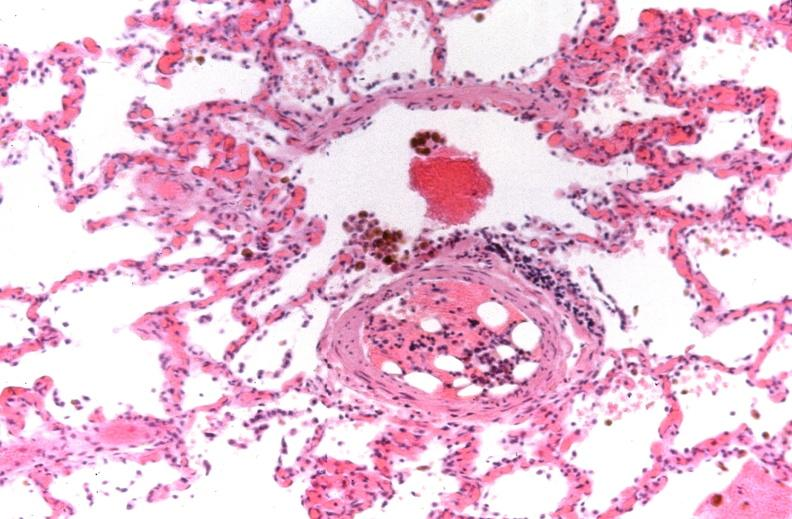s respiratory present?
Answer the question using a single word or phrase. Yes 